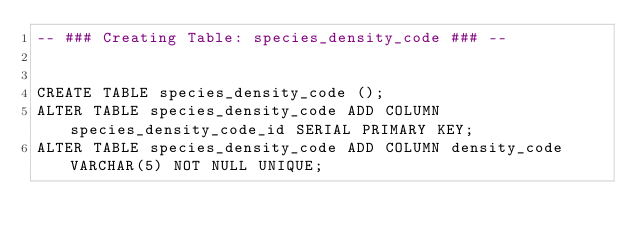<code> <loc_0><loc_0><loc_500><loc_500><_SQL_>-- ### Creating Table: species_density_code ### --

        
CREATE TABLE species_density_code ();
ALTER TABLE species_density_code ADD COLUMN species_density_code_id SERIAL PRIMARY KEY;
ALTER TABLE species_density_code ADD COLUMN density_code VARCHAR(5) NOT NULL UNIQUE;</code> 